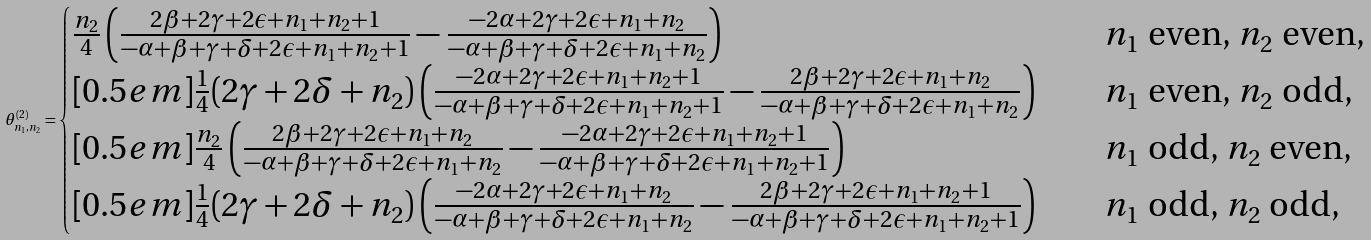<formula> <loc_0><loc_0><loc_500><loc_500>\theta ^ { ( 2 ) } _ { n _ { 1 } , n _ { 2 } } = \begin{cases} \frac { n _ { 2 } } { 4 } \left ( \frac { 2 \beta + 2 \gamma + 2 \epsilon + n _ { 1 } + n _ { 2 } + 1 } { - \alpha + \beta + \gamma + \delta + 2 \epsilon + n _ { 1 } + n _ { 2 } + 1 } - \frac { - 2 \alpha + 2 \gamma + 2 \epsilon + n _ { 1 } + n _ { 2 } } { - \alpha + \beta + \gamma + \delta + 2 \epsilon + n _ { 1 } + n _ { 2 } } \right ) \quad & \text {$n_{1}$ even, $n_{2}$ even,} \\ [ 0 . 5 e m ] \frac { 1 } { 4 } ( 2 \gamma + 2 \delta + n _ { 2 } ) \left ( \frac { - 2 \alpha + 2 \gamma + 2 \epsilon + n _ { 1 } + n _ { 2 } + 1 } { - \alpha + \beta + \gamma + \delta + 2 \epsilon + n _ { 1 } + n _ { 2 } + 1 } - \frac { 2 \beta + 2 \gamma + 2 \epsilon + n _ { 1 } + n _ { 2 } } { - \alpha + \beta + \gamma + \delta + 2 \epsilon + n _ { 1 } + n _ { 2 } } \right ) \quad & \text {$n_{1}$ even, $n_{2}$ odd,} \\ [ 0 . 5 e m ] \frac { n _ { 2 } } { 4 } \left ( \frac { 2 \beta + 2 \gamma + 2 \epsilon + n _ { 1 } + n _ { 2 } } { - \alpha + \beta + \gamma + \delta + 2 \epsilon + n _ { 1 } + n _ { 2 } } - \frac { - 2 \alpha + 2 \gamma + 2 \epsilon + n _ { 1 } + n _ { 2 } + 1 } { - \alpha + \beta + \gamma + \delta + 2 \epsilon + n _ { 1 } + n _ { 2 } + 1 } \right ) \quad & \text {$n_{1}$ odd, $n_{2}$ even,} \\ [ 0 . 5 e m ] \frac { 1 } { 4 } ( 2 \gamma + 2 \delta + n _ { 2 } ) \left ( \frac { - 2 \alpha + 2 \gamma + 2 \epsilon + n _ { 1 } + n _ { 2 } } { - \alpha + \beta + \gamma + \delta + 2 \epsilon + n _ { 1 } + n _ { 2 } } - \frac { 2 \beta + 2 \gamma + 2 \epsilon + n _ { 1 } + n _ { 2 } + 1 } { - \alpha + \beta + \gamma + \delta + 2 \epsilon + n _ { 1 } + n _ { 2 } + 1 } \right ) \quad & \text {$n_{1}$ odd, $n_{2}$ odd,} \end{cases}</formula> 